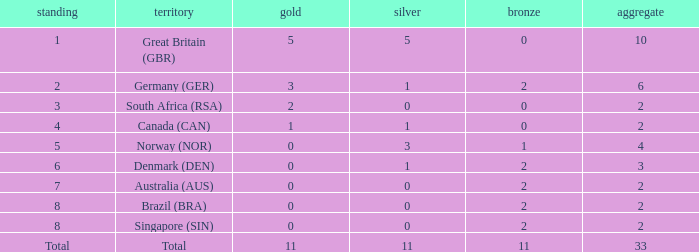What is the least total when the nation is canada (can) and bronze is less than 0? None. I'm looking to parse the entire table for insights. Could you assist me with that? {'header': ['standing', 'territory', 'gold', 'silver', 'bronze', 'aggregate'], 'rows': [['1', 'Great Britain (GBR)', '5', '5', '0', '10'], ['2', 'Germany (GER)', '3', '1', '2', '6'], ['3', 'South Africa (RSA)', '2', '0', '0', '2'], ['4', 'Canada (CAN)', '1', '1', '0', '2'], ['5', 'Norway (NOR)', '0', '3', '1', '4'], ['6', 'Denmark (DEN)', '0', '1', '2', '3'], ['7', 'Australia (AUS)', '0', '0', '2', '2'], ['8', 'Brazil (BRA)', '0', '0', '2', '2'], ['8', 'Singapore (SIN)', '0', '0', '2', '2'], ['Total', 'Total', '11', '11', '11', '33']]} 